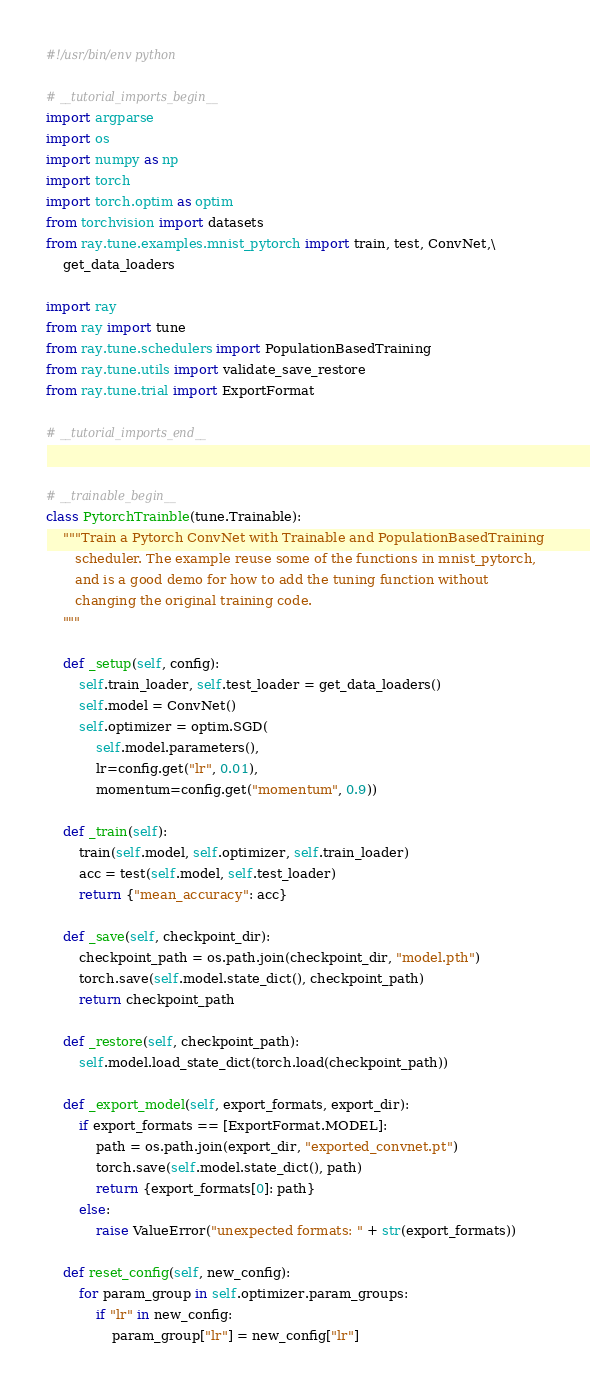<code> <loc_0><loc_0><loc_500><loc_500><_Python_>#!/usr/bin/env python

# __tutorial_imports_begin__
import argparse
import os
import numpy as np
import torch
import torch.optim as optim
from torchvision import datasets
from ray.tune.examples.mnist_pytorch import train, test, ConvNet,\
    get_data_loaders

import ray
from ray import tune
from ray.tune.schedulers import PopulationBasedTraining
from ray.tune.utils import validate_save_restore
from ray.tune.trial import ExportFormat

# __tutorial_imports_end__


# __trainable_begin__
class PytorchTrainble(tune.Trainable):
    """Train a Pytorch ConvNet with Trainable and PopulationBasedTraining
       scheduler. The example reuse some of the functions in mnist_pytorch,
       and is a good demo for how to add the tuning function without
       changing the original training code.
    """

    def _setup(self, config):
        self.train_loader, self.test_loader = get_data_loaders()
        self.model = ConvNet()
        self.optimizer = optim.SGD(
            self.model.parameters(),
            lr=config.get("lr", 0.01),
            momentum=config.get("momentum", 0.9))

    def _train(self):
        train(self.model, self.optimizer, self.train_loader)
        acc = test(self.model, self.test_loader)
        return {"mean_accuracy": acc}

    def _save(self, checkpoint_dir):
        checkpoint_path = os.path.join(checkpoint_dir, "model.pth")
        torch.save(self.model.state_dict(), checkpoint_path)
        return checkpoint_path

    def _restore(self, checkpoint_path):
        self.model.load_state_dict(torch.load(checkpoint_path))

    def _export_model(self, export_formats, export_dir):
        if export_formats == [ExportFormat.MODEL]:
            path = os.path.join(export_dir, "exported_convnet.pt")
            torch.save(self.model.state_dict(), path)
            return {export_formats[0]: path}
        else:
            raise ValueError("unexpected formats: " + str(export_formats))

    def reset_config(self, new_config):
        for param_group in self.optimizer.param_groups:
            if "lr" in new_config:
                param_group["lr"] = new_config["lr"]</code> 